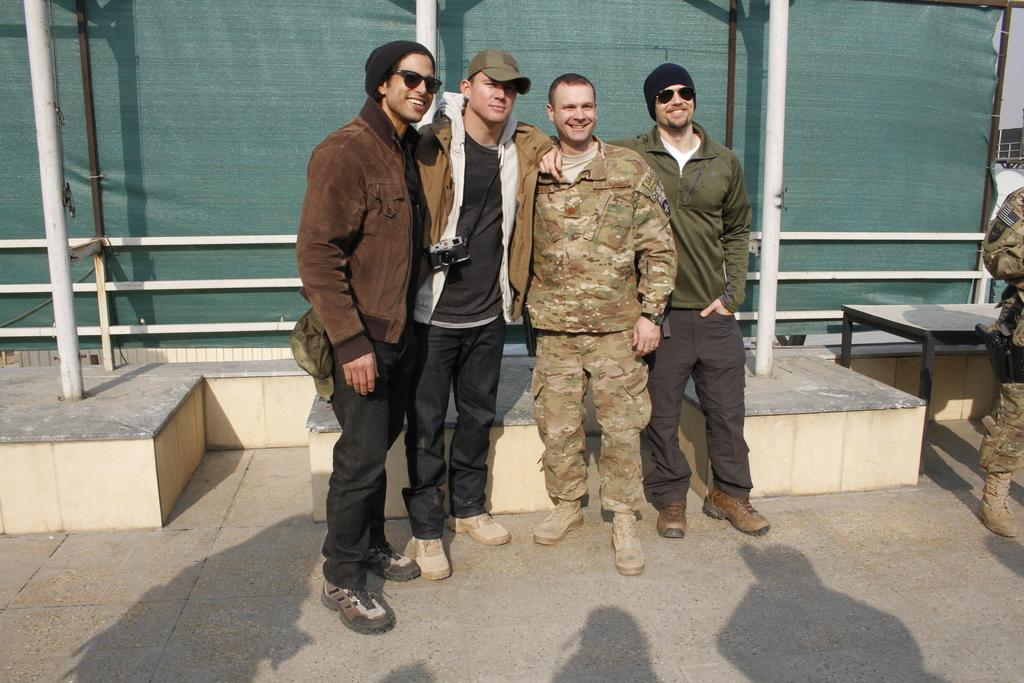Who or what can be seen in the image? There are people in the image. What is the sheet tied to poles used for in the image? The sheet tied to poles is likely being used as a makeshift shelter or shade. What is the purpose of the table in the image? The table might be used for holding food, drinks, or other items. What can be observed about the people in the image? Shadows of people are visible on the ground in the image. Are there any cacti visible in the image? There is no mention of cacti in the provided facts, so we cannot determine if any are present in the image. 